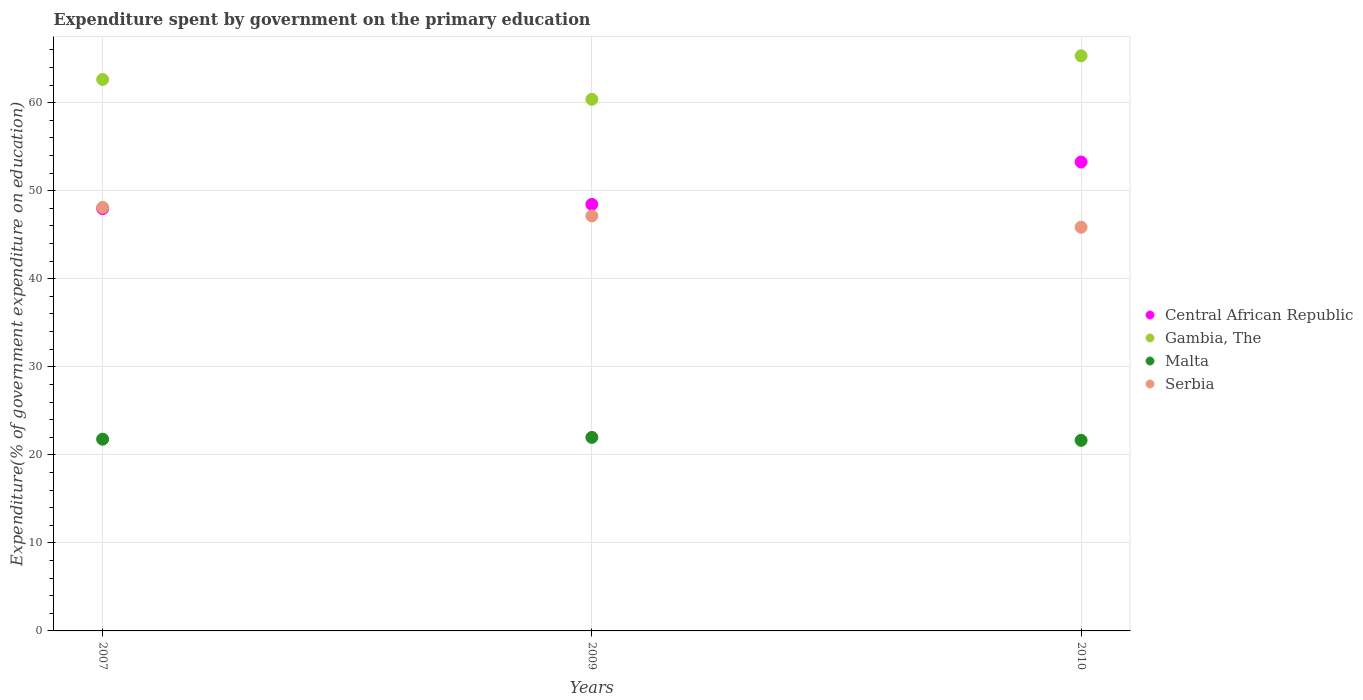How many different coloured dotlines are there?
Your answer should be very brief. 4. Is the number of dotlines equal to the number of legend labels?
Offer a very short reply. Yes. What is the expenditure spent by government on the primary education in Serbia in 2007?
Ensure brevity in your answer.  48.11. Across all years, what is the maximum expenditure spent by government on the primary education in Central African Republic?
Your response must be concise. 53.26. Across all years, what is the minimum expenditure spent by government on the primary education in Malta?
Your answer should be compact. 21.65. What is the total expenditure spent by government on the primary education in Gambia, The in the graph?
Give a very brief answer. 188.36. What is the difference between the expenditure spent by government on the primary education in Central African Republic in 2009 and that in 2010?
Your answer should be very brief. -4.81. What is the difference between the expenditure spent by government on the primary education in Gambia, The in 2010 and the expenditure spent by government on the primary education in Central African Republic in 2009?
Give a very brief answer. 16.88. What is the average expenditure spent by government on the primary education in Central African Republic per year?
Your answer should be compact. 49.89. In the year 2010, what is the difference between the expenditure spent by government on the primary education in Gambia, The and expenditure spent by government on the primary education in Malta?
Offer a terse response. 43.68. What is the ratio of the expenditure spent by government on the primary education in Central African Republic in 2007 to that in 2010?
Make the answer very short. 0.9. What is the difference between the highest and the second highest expenditure spent by government on the primary education in Malta?
Your response must be concise. 0.2. What is the difference between the highest and the lowest expenditure spent by government on the primary education in Central African Republic?
Keep it short and to the point. 5.3. Is the sum of the expenditure spent by government on the primary education in Serbia in 2007 and 2009 greater than the maximum expenditure spent by government on the primary education in Central African Republic across all years?
Your response must be concise. Yes. Is it the case that in every year, the sum of the expenditure spent by government on the primary education in Central African Republic and expenditure spent by government on the primary education in Malta  is greater than the expenditure spent by government on the primary education in Serbia?
Your response must be concise. Yes. What is the difference between two consecutive major ticks on the Y-axis?
Offer a terse response. 10. Does the graph contain grids?
Make the answer very short. Yes. Where does the legend appear in the graph?
Offer a terse response. Center right. How are the legend labels stacked?
Offer a very short reply. Vertical. What is the title of the graph?
Provide a short and direct response. Expenditure spent by government on the primary education. Does "Guinea" appear as one of the legend labels in the graph?
Provide a short and direct response. No. What is the label or title of the Y-axis?
Your response must be concise. Expenditure(% of government expenditure on education). What is the Expenditure(% of government expenditure on education) of Central African Republic in 2007?
Keep it short and to the point. 47.96. What is the Expenditure(% of government expenditure on education) of Gambia, The in 2007?
Your response must be concise. 62.64. What is the Expenditure(% of government expenditure on education) of Malta in 2007?
Give a very brief answer. 21.78. What is the Expenditure(% of government expenditure on education) of Serbia in 2007?
Your answer should be compact. 48.11. What is the Expenditure(% of government expenditure on education) of Central African Republic in 2009?
Provide a succinct answer. 48.45. What is the Expenditure(% of government expenditure on education) in Gambia, The in 2009?
Your answer should be very brief. 60.39. What is the Expenditure(% of government expenditure on education) of Malta in 2009?
Your response must be concise. 21.98. What is the Expenditure(% of government expenditure on education) in Serbia in 2009?
Your response must be concise. 47.14. What is the Expenditure(% of government expenditure on education) in Central African Republic in 2010?
Give a very brief answer. 53.26. What is the Expenditure(% of government expenditure on education) in Gambia, The in 2010?
Offer a very short reply. 65.33. What is the Expenditure(% of government expenditure on education) of Malta in 2010?
Your answer should be very brief. 21.65. What is the Expenditure(% of government expenditure on education) of Serbia in 2010?
Your answer should be very brief. 45.86. Across all years, what is the maximum Expenditure(% of government expenditure on education) of Central African Republic?
Offer a terse response. 53.26. Across all years, what is the maximum Expenditure(% of government expenditure on education) in Gambia, The?
Your answer should be very brief. 65.33. Across all years, what is the maximum Expenditure(% of government expenditure on education) in Malta?
Keep it short and to the point. 21.98. Across all years, what is the maximum Expenditure(% of government expenditure on education) in Serbia?
Provide a succinct answer. 48.11. Across all years, what is the minimum Expenditure(% of government expenditure on education) in Central African Republic?
Offer a very short reply. 47.96. Across all years, what is the minimum Expenditure(% of government expenditure on education) of Gambia, The?
Ensure brevity in your answer.  60.39. Across all years, what is the minimum Expenditure(% of government expenditure on education) in Malta?
Provide a short and direct response. 21.65. Across all years, what is the minimum Expenditure(% of government expenditure on education) in Serbia?
Provide a succinct answer. 45.86. What is the total Expenditure(% of government expenditure on education) of Central African Republic in the graph?
Your answer should be very brief. 149.68. What is the total Expenditure(% of government expenditure on education) in Gambia, The in the graph?
Your response must be concise. 188.36. What is the total Expenditure(% of government expenditure on education) of Malta in the graph?
Your answer should be compact. 65.41. What is the total Expenditure(% of government expenditure on education) in Serbia in the graph?
Your response must be concise. 141.1. What is the difference between the Expenditure(% of government expenditure on education) of Central African Republic in 2007 and that in 2009?
Your response must be concise. -0.49. What is the difference between the Expenditure(% of government expenditure on education) in Gambia, The in 2007 and that in 2009?
Provide a short and direct response. 2.25. What is the difference between the Expenditure(% of government expenditure on education) in Malta in 2007 and that in 2009?
Offer a terse response. -0.2. What is the difference between the Expenditure(% of government expenditure on education) in Serbia in 2007 and that in 2009?
Offer a terse response. 0.98. What is the difference between the Expenditure(% of government expenditure on education) of Central African Republic in 2007 and that in 2010?
Offer a very short reply. -5.3. What is the difference between the Expenditure(% of government expenditure on education) of Gambia, The in 2007 and that in 2010?
Your response must be concise. -2.69. What is the difference between the Expenditure(% of government expenditure on education) in Malta in 2007 and that in 2010?
Ensure brevity in your answer.  0.13. What is the difference between the Expenditure(% of government expenditure on education) in Serbia in 2007 and that in 2010?
Offer a terse response. 2.26. What is the difference between the Expenditure(% of government expenditure on education) in Central African Republic in 2009 and that in 2010?
Offer a very short reply. -4.81. What is the difference between the Expenditure(% of government expenditure on education) of Gambia, The in 2009 and that in 2010?
Keep it short and to the point. -4.94. What is the difference between the Expenditure(% of government expenditure on education) of Malta in 2009 and that in 2010?
Your answer should be very brief. 0.34. What is the difference between the Expenditure(% of government expenditure on education) of Serbia in 2009 and that in 2010?
Your response must be concise. 1.28. What is the difference between the Expenditure(% of government expenditure on education) in Central African Republic in 2007 and the Expenditure(% of government expenditure on education) in Gambia, The in 2009?
Ensure brevity in your answer.  -12.43. What is the difference between the Expenditure(% of government expenditure on education) in Central African Republic in 2007 and the Expenditure(% of government expenditure on education) in Malta in 2009?
Your answer should be compact. 25.98. What is the difference between the Expenditure(% of government expenditure on education) in Central African Republic in 2007 and the Expenditure(% of government expenditure on education) in Serbia in 2009?
Make the answer very short. 0.83. What is the difference between the Expenditure(% of government expenditure on education) of Gambia, The in 2007 and the Expenditure(% of government expenditure on education) of Malta in 2009?
Keep it short and to the point. 40.66. What is the difference between the Expenditure(% of government expenditure on education) in Gambia, The in 2007 and the Expenditure(% of government expenditure on education) in Serbia in 2009?
Your answer should be compact. 15.51. What is the difference between the Expenditure(% of government expenditure on education) of Malta in 2007 and the Expenditure(% of government expenditure on education) of Serbia in 2009?
Give a very brief answer. -25.36. What is the difference between the Expenditure(% of government expenditure on education) of Central African Republic in 2007 and the Expenditure(% of government expenditure on education) of Gambia, The in 2010?
Offer a very short reply. -17.36. What is the difference between the Expenditure(% of government expenditure on education) in Central African Republic in 2007 and the Expenditure(% of government expenditure on education) in Malta in 2010?
Offer a terse response. 26.32. What is the difference between the Expenditure(% of government expenditure on education) of Central African Republic in 2007 and the Expenditure(% of government expenditure on education) of Serbia in 2010?
Provide a short and direct response. 2.11. What is the difference between the Expenditure(% of government expenditure on education) in Gambia, The in 2007 and the Expenditure(% of government expenditure on education) in Malta in 2010?
Keep it short and to the point. 40.99. What is the difference between the Expenditure(% of government expenditure on education) of Gambia, The in 2007 and the Expenditure(% of government expenditure on education) of Serbia in 2010?
Provide a succinct answer. 16.79. What is the difference between the Expenditure(% of government expenditure on education) in Malta in 2007 and the Expenditure(% of government expenditure on education) in Serbia in 2010?
Keep it short and to the point. -24.08. What is the difference between the Expenditure(% of government expenditure on education) in Central African Republic in 2009 and the Expenditure(% of government expenditure on education) in Gambia, The in 2010?
Offer a terse response. -16.88. What is the difference between the Expenditure(% of government expenditure on education) in Central African Republic in 2009 and the Expenditure(% of government expenditure on education) in Malta in 2010?
Offer a very short reply. 26.8. What is the difference between the Expenditure(% of government expenditure on education) in Central African Republic in 2009 and the Expenditure(% of government expenditure on education) in Serbia in 2010?
Provide a succinct answer. 2.59. What is the difference between the Expenditure(% of government expenditure on education) in Gambia, The in 2009 and the Expenditure(% of government expenditure on education) in Malta in 2010?
Make the answer very short. 38.74. What is the difference between the Expenditure(% of government expenditure on education) of Gambia, The in 2009 and the Expenditure(% of government expenditure on education) of Serbia in 2010?
Offer a terse response. 14.53. What is the difference between the Expenditure(% of government expenditure on education) of Malta in 2009 and the Expenditure(% of government expenditure on education) of Serbia in 2010?
Offer a terse response. -23.87. What is the average Expenditure(% of government expenditure on education) in Central African Republic per year?
Give a very brief answer. 49.89. What is the average Expenditure(% of government expenditure on education) of Gambia, The per year?
Give a very brief answer. 62.79. What is the average Expenditure(% of government expenditure on education) of Malta per year?
Make the answer very short. 21.8. What is the average Expenditure(% of government expenditure on education) of Serbia per year?
Keep it short and to the point. 47.03. In the year 2007, what is the difference between the Expenditure(% of government expenditure on education) of Central African Republic and Expenditure(% of government expenditure on education) of Gambia, The?
Offer a terse response. -14.68. In the year 2007, what is the difference between the Expenditure(% of government expenditure on education) of Central African Republic and Expenditure(% of government expenditure on education) of Malta?
Offer a very short reply. 26.18. In the year 2007, what is the difference between the Expenditure(% of government expenditure on education) of Central African Republic and Expenditure(% of government expenditure on education) of Serbia?
Keep it short and to the point. -0.15. In the year 2007, what is the difference between the Expenditure(% of government expenditure on education) in Gambia, The and Expenditure(% of government expenditure on education) in Malta?
Offer a terse response. 40.86. In the year 2007, what is the difference between the Expenditure(% of government expenditure on education) in Gambia, The and Expenditure(% of government expenditure on education) in Serbia?
Your response must be concise. 14.53. In the year 2007, what is the difference between the Expenditure(% of government expenditure on education) in Malta and Expenditure(% of government expenditure on education) in Serbia?
Keep it short and to the point. -26.33. In the year 2009, what is the difference between the Expenditure(% of government expenditure on education) in Central African Republic and Expenditure(% of government expenditure on education) in Gambia, The?
Your answer should be compact. -11.94. In the year 2009, what is the difference between the Expenditure(% of government expenditure on education) in Central African Republic and Expenditure(% of government expenditure on education) in Malta?
Provide a succinct answer. 26.47. In the year 2009, what is the difference between the Expenditure(% of government expenditure on education) in Central African Republic and Expenditure(% of government expenditure on education) in Serbia?
Ensure brevity in your answer.  1.31. In the year 2009, what is the difference between the Expenditure(% of government expenditure on education) in Gambia, The and Expenditure(% of government expenditure on education) in Malta?
Give a very brief answer. 38.41. In the year 2009, what is the difference between the Expenditure(% of government expenditure on education) in Gambia, The and Expenditure(% of government expenditure on education) in Serbia?
Make the answer very short. 13.25. In the year 2009, what is the difference between the Expenditure(% of government expenditure on education) in Malta and Expenditure(% of government expenditure on education) in Serbia?
Keep it short and to the point. -25.15. In the year 2010, what is the difference between the Expenditure(% of government expenditure on education) in Central African Republic and Expenditure(% of government expenditure on education) in Gambia, The?
Offer a very short reply. -12.06. In the year 2010, what is the difference between the Expenditure(% of government expenditure on education) in Central African Republic and Expenditure(% of government expenditure on education) in Malta?
Offer a terse response. 31.62. In the year 2010, what is the difference between the Expenditure(% of government expenditure on education) of Central African Republic and Expenditure(% of government expenditure on education) of Serbia?
Ensure brevity in your answer.  7.41. In the year 2010, what is the difference between the Expenditure(% of government expenditure on education) of Gambia, The and Expenditure(% of government expenditure on education) of Malta?
Provide a short and direct response. 43.68. In the year 2010, what is the difference between the Expenditure(% of government expenditure on education) of Gambia, The and Expenditure(% of government expenditure on education) of Serbia?
Give a very brief answer. 19.47. In the year 2010, what is the difference between the Expenditure(% of government expenditure on education) of Malta and Expenditure(% of government expenditure on education) of Serbia?
Your answer should be compact. -24.21. What is the ratio of the Expenditure(% of government expenditure on education) in Central African Republic in 2007 to that in 2009?
Provide a short and direct response. 0.99. What is the ratio of the Expenditure(% of government expenditure on education) of Gambia, The in 2007 to that in 2009?
Provide a short and direct response. 1.04. What is the ratio of the Expenditure(% of government expenditure on education) of Malta in 2007 to that in 2009?
Your response must be concise. 0.99. What is the ratio of the Expenditure(% of government expenditure on education) in Serbia in 2007 to that in 2009?
Your answer should be compact. 1.02. What is the ratio of the Expenditure(% of government expenditure on education) of Central African Republic in 2007 to that in 2010?
Make the answer very short. 0.9. What is the ratio of the Expenditure(% of government expenditure on education) of Gambia, The in 2007 to that in 2010?
Your response must be concise. 0.96. What is the ratio of the Expenditure(% of government expenditure on education) of Malta in 2007 to that in 2010?
Provide a short and direct response. 1.01. What is the ratio of the Expenditure(% of government expenditure on education) in Serbia in 2007 to that in 2010?
Keep it short and to the point. 1.05. What is the ratio of the Expenditure(% of government expenditure on education) in Central African Republic in 2009 to that in 2010?
Give a very brief answer. 0.91. What is the ratio of the Expenditure(% of government expenditure on education) in Gambia, The in 2009 to that in 2010?
Provide a short and direct response. 0.92. What is the ratio of the Expenditure(% of government expenditure on education) in Malta in 2009 to that in 2010?
Your answer should be compact. 1.02. What is the ratio of the Expenditure(% of government expenditure on education) in Serbia in 2009 to that in 2010?
Ensure brevity in your answer.  1.03. What is the difference between the highest and the second highest Expenditure(% of government expenditure on education) in Central African Republic?
Provide a succinct answer. 4.81. What is the difference between the highest and the second highest Expenditure(% of government expenditure on education) in Gambia, The?
Provide a succinct answer. 2.69. What is the difference between the highest and the second highest Expenditure(% of government expenditure on education) in Malta?
Ensure brevity in your answer.  0.2. What is the difference between the highest and the second highest Expenditure(% of government expenditure on education) in Serbia?
Keep it short and to the point. 0.98. What is the difference between the highest and the lowest Expenditure(% of government expenditure on education) of Central African Republic?
Ensure brevity in your answer.  5.3. What is the difference between the highest and the lowest Expenditure(% of government expenditure on education) of Gambia, The?
Make the answer very short. 4.94. What is the difference between the highest and the lowest Expenditure(% of government expenditure on education) in Malta?
Make the answer very short. 0.34. What is the difference between the highest and the lowest Expenditure(% of government expenditure on education) in Serbia?
Offer a terse response. 2.26. 